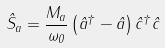Convert formula to latex. <formula><loc_0><loc_0><loc_500><loc_500>\hat { S } _ { a } = \frac { M _ { a } } { \omega _ { 0 } } \left ( \hat { a } ^ { \dagger } - \hat { a } \right ) \hat { c } ^ { \dagger } \hat { c }</formula> 